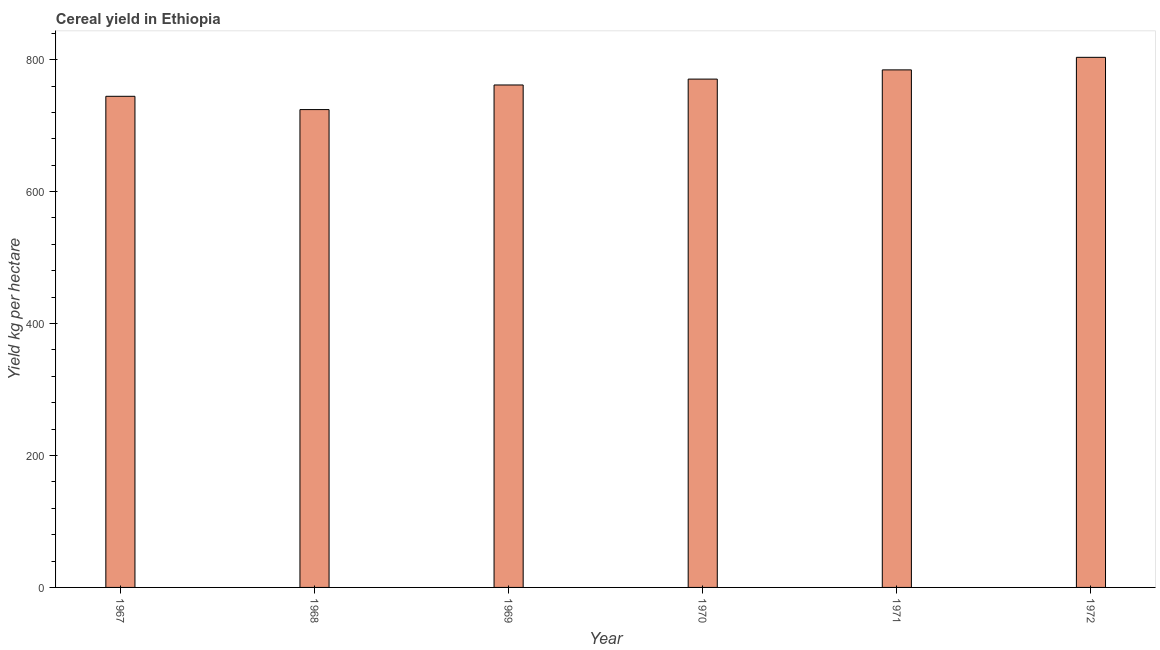Does the graph contain grids?
Offer a very short reply. No. What is the title of the graph?
Keep it short and to the point. Cereal yield in Ethiopia. What is the label or title of the Y-axis?
Offer a very short reply. Yield kg per hectare. What is the cereal yield in 1967?
Provide a short and direct response. 744.45. Across all years, what is the maximum cereal yield?
Your answer should be compact. 803.53. Across all years, what is the minimum cereal yield?
Your response must be concise. 724.31. In which year was the cereal yield maximum?
Your answer should be compact. 1972. In which year was the cereal yield minimum?
Make the answer very short. 1968. What is the sum of the cereal yield?
Your answer should be very brief. 4588.96. What is the difference between the cereal yield in 1970 and 1971?
Ensure brevity in your answer.  -13.97. What is the average cereal yield per year?
Provide a short and direct response. 764.83. What is the median cereal yield?
Your answer should be very brief. 766.08. Is the difference between the cereal yield in 1969 and 1972 greater than the difference between any two years?
Ensure brevity in your answer.  No. What is the difference between the highest and the second highest cereal yield?
Keep it short and to the point. 19.02. Is the sum of the cereal yield in 1968 and 1969 greater than the maximum cereal yield across all years?
Ensure brevity in your answer.  Yes. What is the difference between the highest and the lowest cereal yield?
Provide a succinct answer. 79.22. In how many years, is the cereal yield greater than the average cereal yield taken over all years?
Offer a terse response. 3. How many years are there in the graph?
Provide a short and direct response. 6. What is the Yield kg per hectare of 1967?
Your answer should be very brief. 744.45. What is the Yield kg per hectare of 1968?
Your answer should be compact. 724.31. What is the Yield kg per hectare of 1969?
Give a very brief answer. 761.62. What is the Yield kg per hectare of 1970?
Your response must be concise. 770.54. What is the Yield kg per hectare of 1971?
Your response must be concise. 784.51. What is the Yield kg per hectare in 1972?
Offer a terse response. 803.53. What is the difference between the Yield kg per hectare in 1967 and 1968?
Keep it short and to the point. 20.14. What is the difference between the Yield kg per hectare in 1967 and 1969?
Keep it short and to the point. -17.18. What is the difference between the Yield kg per hectare in 1967 and 1970?
Provide a short and direct response. -26.09. What is the difference between the Yield kg per hectare in 1967 and 1971?
Ensure brevity in your answer.  -40.06. What is the difference between the Yield kg per hectare in 1967 and 1972?
Ensure brevity in your answer.  -59.08. What is the difference between the Yield kg per hectare in 1968 and 1969?
Provide a succinct answer. -37.31. What is the difference between the Yield kg per hectare in 1968 and 1970?
Your response must be concise. -46.23. What is the difference between the Yield kg per hectare in 1968 and 1971?
Offer a very short reply. -60.2. What is the difference between the Yield kg per hectare in 1968 and 1972?
Offer a terse response. -79.22. What is the difference between the Yield kg per hectare in 1969 and 1970?
Your answer should be very brief. -8.92. What is the difference between the Yield kg per hectare in 1969 and 1971?
Keep it short and to the point. -22.88. What is the difference between the Yield kg per hectare in 1969 and 1972?
Your answer should be very brief. -41.91. What is the difference between the Yield kg per hectare in 1970 and 1971?
Your response must be concise. -13.97. What is the difference between the Yield kg per hectare in 1970 and 1972?
Offer a terse response. -32.99. What is the difference between the Yield kg per hectare in 1971 and 1972?
Keep it short and to the point. -19.02. What is the ratio of the Yield kg per hectare in 1967 to that in 1968?
Ensure brevity in your answer.  1.03. What is the ratio of the Yield kg per hectare in 1967 to that in 1969?
Your response must be concise. 0.98. What is the ratio of the Yield kg per hectare in 1967 to that in 1970?
Provide a succinct answer. 0.97. What is the ratio of the Yield kg per hectare in 1967 to that in 1971?
Your answer should be very brief. 0.95. What is the ratio of the Yield kg per hectare in 1967 to that in 1972?
Provide a short and direct response. 0.93. What is the ratio of the Yield kg per hectare in 1968 to that in 1969?
Keep it short and to the point. 0.95. What is the ratio of the Yield kg per hectare in 1968 to that in 1970?
Your answer should be compact. 0.94. What is the ratio of the Yield kg per hectare in 1968 to that in 1971?
Provide a succinct answer. 0.92. What is the ratio of the Yield kg per hectare in 1968 to that in 1972?
Make the answer very short. 0.9. What is the ratio of the Yield kg per hectare in 1969 to that in 1972?
Give a very brief answer. 0.95. 